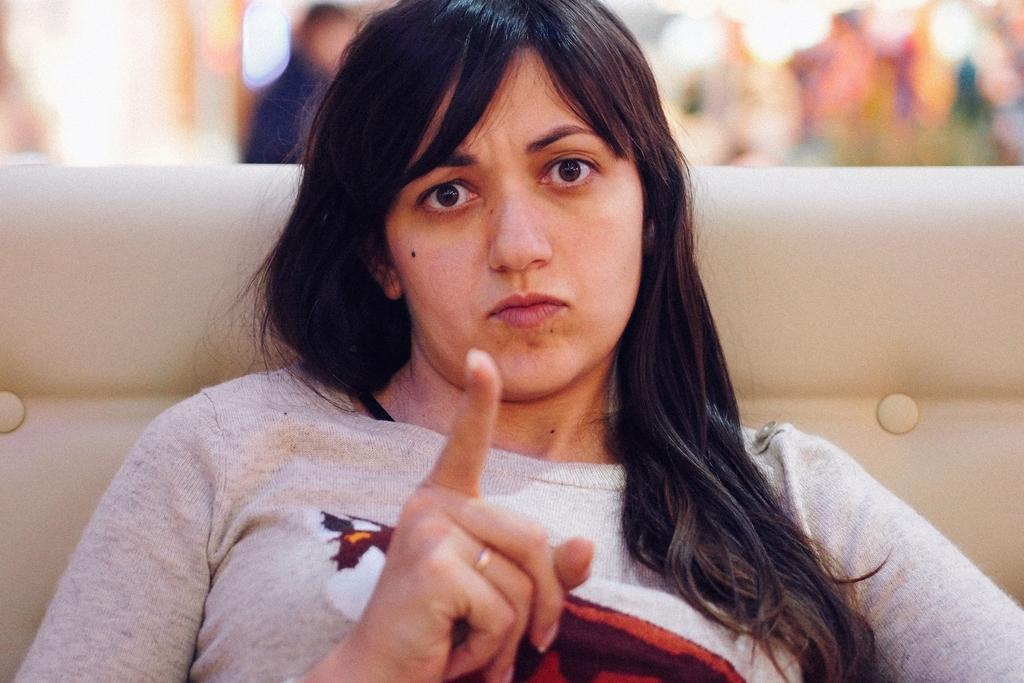Describe this image in one or two sentences. In this picture there is a woman who is wearing t-shirt and sitting on the couch. In the background we can see a man who is standing near to the wall. Here we can see lights. 